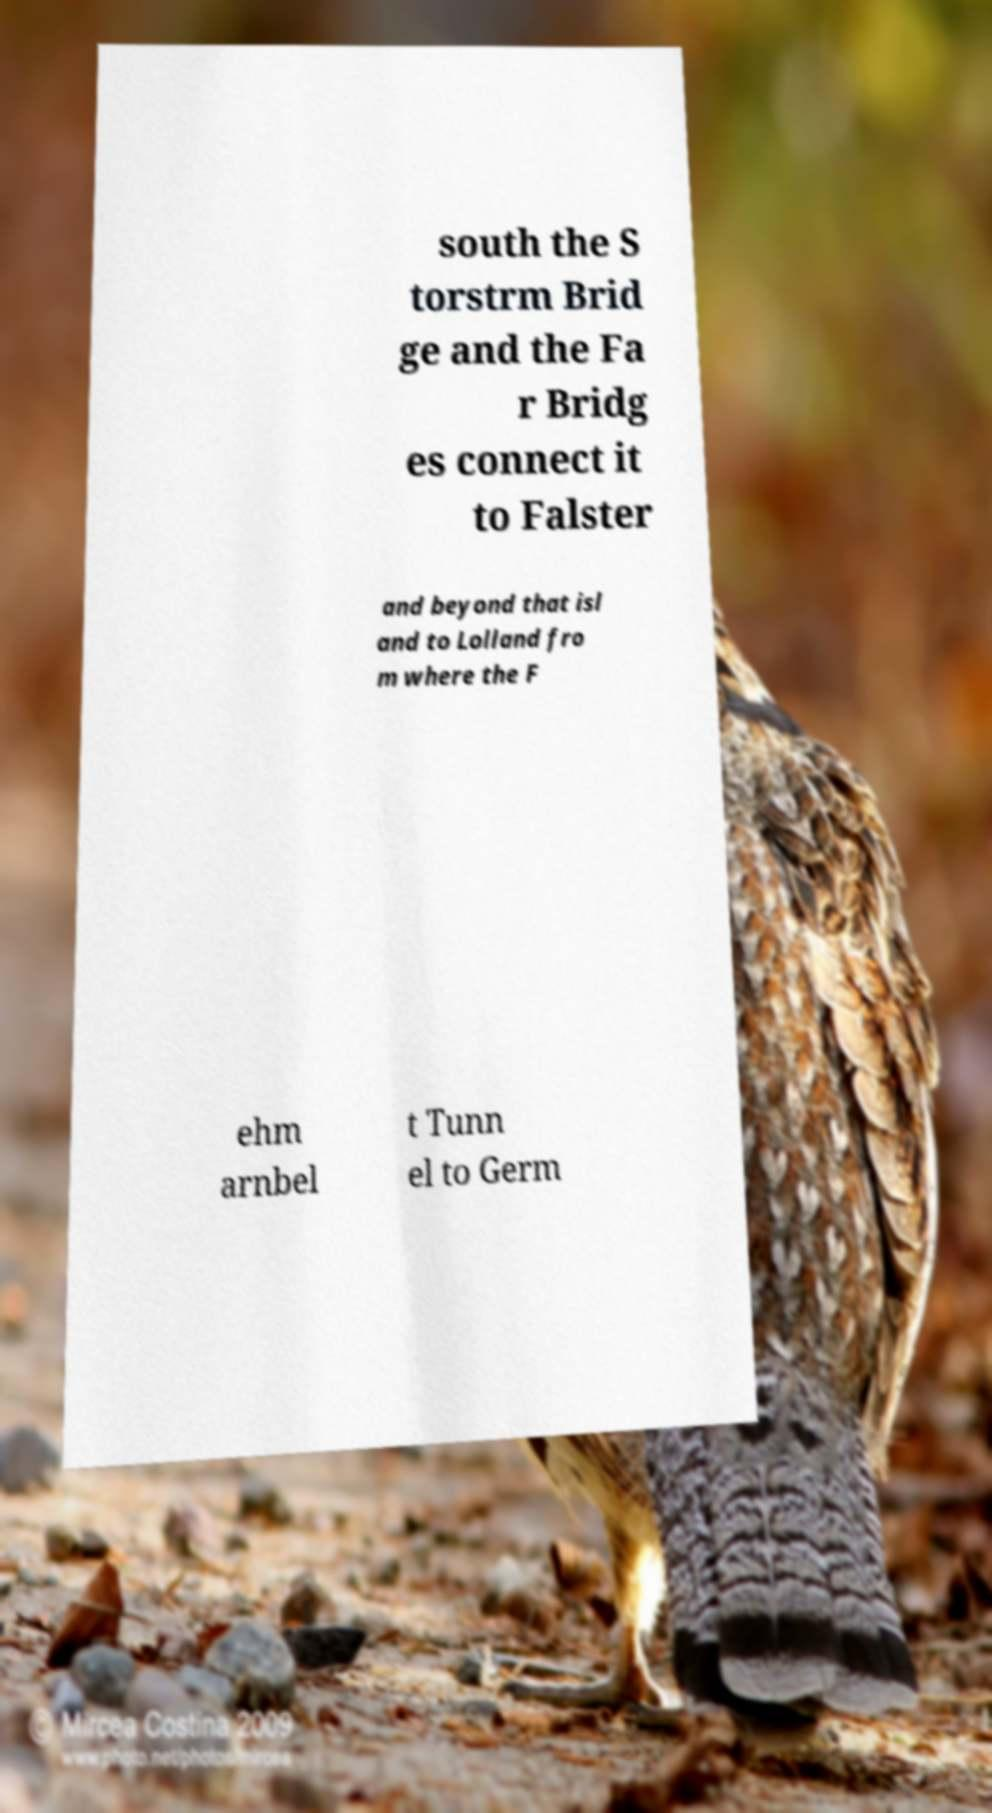Could you extract and type out the text from this image? south the S torstrm Brid ge and the Fa r Bridg es connect it to Falster and beyond that isl and to Lolland fro m where the F ehm arnbel t Tunn el to Germ 